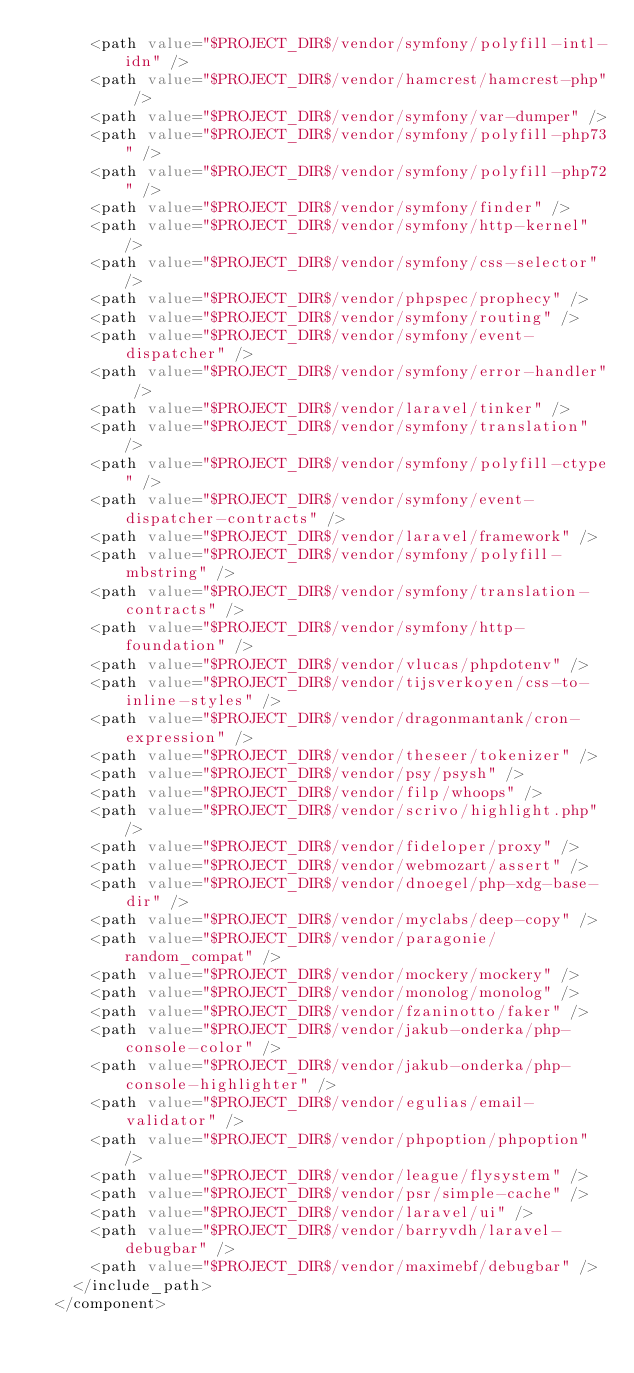<code> <loc_0><loc_0><loc_500><loc_500><_XML_>      <path value="$PROJECT_DIR$/vendor/symfony/polyfill-intl-idn" />
      <path value="$PROJECT_DIR$/vendor/hamcrest/hamcrest-php" />
      <path value="$PROJECT_DIR$/vendor/symfony/var-dumper" />
      <path value="$PROJECT_DIR$/vendor/symfony/polyfill-php73" />
      <path value="$PROJECT_DIR$/vendor/symfony/polyfill-php72" />
      <path value="$PROJECT_DIR$/vendor/symfony/finder" />
      <path value="$PROJECT_DIR$/vendor/symfony/http-kernel" />
      <path value="$PROJECT_DIR$/vendor/symfony/css-selector" />
      <path value="$PROJECT_DIR$/vendor/phpspec/prophecy" />
      <path value="$PROJECT_DIR$/vendor/symfony/routing" />
      <path value="$PROJECT_DIR$/vendor/symfony/event-dispatcher" />
      <path value="$PROJECT_DIR$/vendor/symfony/error-handler" />
      <path value="$PROJECT_DIR$/vendor/laravel/tinker" />
      <path value="$PROJECT_DIR$/vendor/symfony/translation" />
      <path value="$PROJECT_DIR$/vendor/symfony/polyfill-ctype" />
      <path value="$PROJECT_DIR$/vendor/symfony/event-dispatcher-contracts" />
      <path value="$PROJECT_DIR$/vendor/laravel/framework" />
      <path value="$PROJECT_DIR$/vendor/symfony/polyfill-mbstring" />
      <path value="$PROJECT_DIR$/vendor/symfony/translation-contracts" />
      <path value="$PROJECT_DIR$/vendor/symfony/http-foundation" />
      <path value="$PROJECT_DIR$/vendor/vlucas/phpdotenv" />
      <path value="$PROJECT_DIR$/vendor/tijsverkoyen/css-to-inline-styles" />
      <path value="$PROJECT_DIR$/vendor/dragonmantank/cron-expression" />
      <path value="$PROJECT_DIR$/vendor/theseer/tokenizer" />
      <path value="$PROJECT_DIR$/vendor/psy/psysh" />
      <path value="$PROJECT_DIR$/vendor/filp/whoops" />
      <path value="$PROJECT_DIR$/vendor/scrivo/highlight.php" />
      <path value="$PROJECT_DIR$/vendor/fideloper/proxy" />
      <path value="$PROJECT_DIR$/vendor/webmozart/assert" />
      <path value="$PROJECT_DIR$/vendor/dnoegel/php-xdg-base-dir" />
      <path value="$PROJECT_DIR$/vendor/myclabs/deep-copy" />
      <path value="$PROJECT_DIR$/vendor/paragonie/random_compat" />
      <path value="$PROJECT_DIR$/vendor/mockery/mockery" />
      <path value="$PROJECT_DIR$/vendor/monolog/monolog" />
      <path value="$PROJECT_DIR$/vendor/fzaninotto/faker" />
      <path value="$PROJECT_DIR$/vendor/jakub-onderka/php-console-color" />
      <path value="$PROJECT_DIR$/vendor/jakub-onderka/php-console-highlighter" />
      <path value="$PROJECT_DIR$/vendor/egulias/email-validator" />
      <path value="$PROJECT_DIR$/vendor/phpoption/phpoption" />
      <path value="$PROJECT_DIR$/vendor/league/flysystem" />
      <path value="$PROJECT_DIR$/vendor/psr/simple-cache" />
      <path value="$PROJECT_DIR$/vendor/laravel/ui" />
      <path value="$PROJECT_DIR$/vendor/barryvdh/laravel-debugbar" />
      <path value="$PROJECT_DIR$/vendor/maximebf/debugbar" />
    </include_path>
  </component></code> 